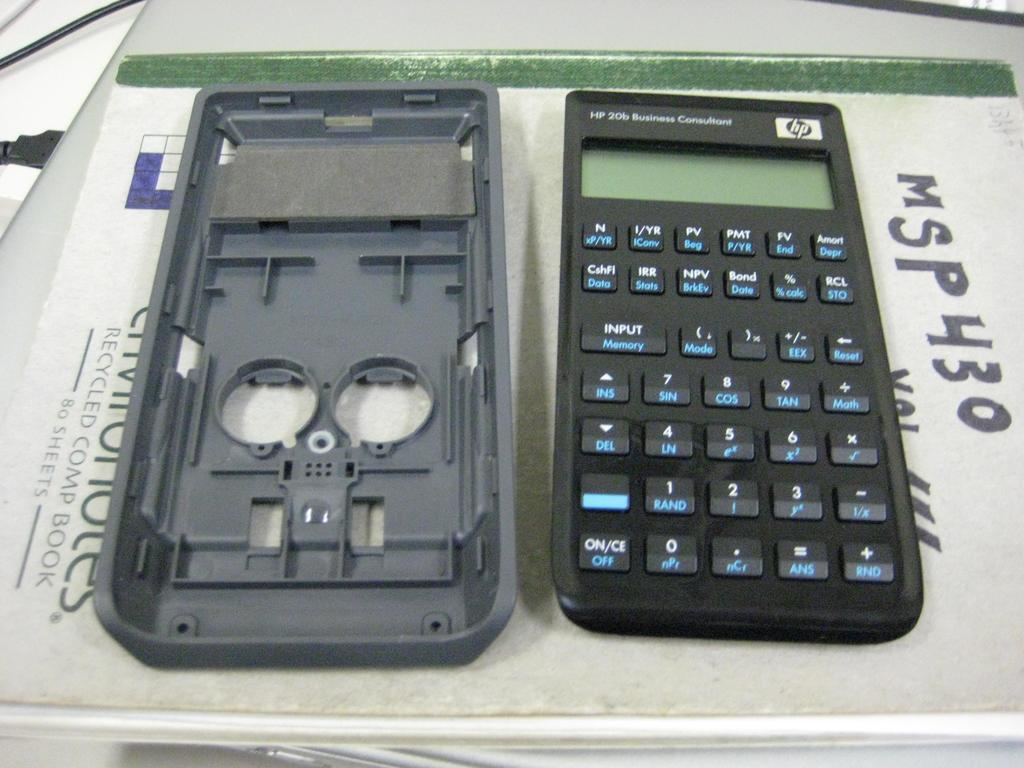<image>
Present a compact description of the photo's key features. a black calculator laying next to the letters and numbers 'msp430' 